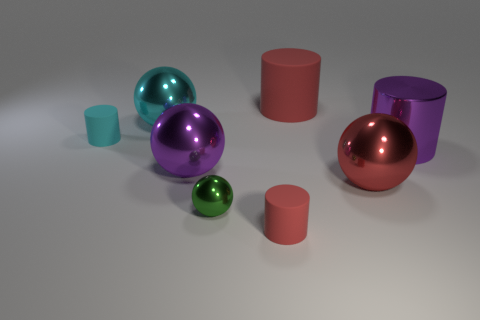Are there any things that have the same color as the metal cylinder?
Keep it short and to the point. Yes. There is a red matte cylinder behind the large cylinder that is to the right of the large matte cylinder; are there any metallic objects to the right of it?
Offer a very short reply. Yes. How many tiny things are red spheres or cyan rubber cylinders?
Provide a short and direct response. 1. There is a rubber object that is the same size as the cyan matte cylinder; what is its color?
Keep it short and to the point. Red. What number of purple things are on the left side of the tiny shiny thing?
Offer a terse response. 1. Are there any tiny objects that have the same material as the cyan cylinder?
Provide a succinct answer. Yes. There is a metallic thing that is the same color as the big matte thing; what is its shape?
Provide a succinct answer. Sphere. What is the color of the rubber object in front of the tiny sphere?
Provide a short and direct response. Red. Are there an equal number of rubber things that are to the left of the big shiny cylinder and purple metal cylinders that are on the right side of the large red matte cylinder?
Offer a very short reply. No. What material is the purple thing behind the purple metallic object that is on the left side of the red sphere made of?
Offer a very short reply. Metal. 